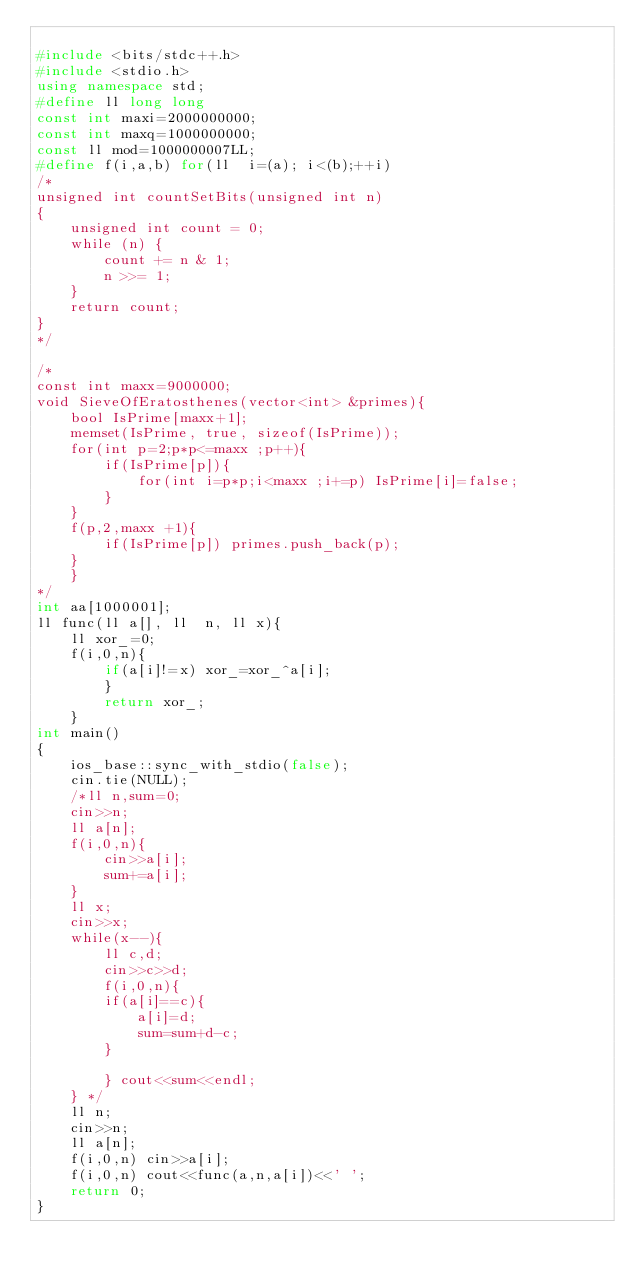<code> <loc_0><loc_0><loc_500><loc_500><_C++_>
#include <bits/stdc++.h>
#include <stdio.h>
using namespace std;
#define ll long long
const int maxi=2000000000;
const int maxq=1000000000;
const ll mod=1000000007LL;
#define f(i,a,b) for(ll  i=(a); i<(b);++i)
/*
unsigned int countSetBits(unsigned int n)
{
    unsigned int count = 0;
    while (n) {
        count += n & 1;
        n >>= 1;
    }
    return count;
}
*/

/*
const int maxx=9000000;
void SieveOfEratosthenes(vector<int> &primes){
    bool IsPrime[maxx+1];
    memset(IsPrime, true, sizeof(IsPrime));
    for(int p=2;p*p<=maxx ;p++){
        if(IsPrime[p]){
            for(int i=p*p;i<maxx ;i+=p) IsPrime[i]=false;
        }
    }
    f(p,2,maxx +1){
        if(IsPrime[p]) primes.push_back(p);
    }
    }
*/
int aa[1000001];
ll func(ll a[], ll  n, ll x){
    ll xor_=0;
    f(i,0,n){
        if(a[i]!=x) xor_=xor_^a[i];
        }
        return xor_;
    }
int main()
{
    ios_base::sync_with_stdio(false);
    cin.tie(NULL);
    /*ll n,sum=0;
    cin>>n;
    ll a[n];
    f(i,0,n){
        cin>>a[i];
        sum+=a[i];
    }
    ll x;
    cin>>x;
    while(x--){
        ll c,d;
        cin>>c>>d;
        f(i,0,n){
        if(a[i]==c){
            a[i]=d;
            sum=sum+d-c;
        }

        } cout<<sum<<endl;
    } */
    ll n;
    cin>>n;
    ll a[n];
    f(i,0,n) cin>>a[i];
    f(i,0,n) cout<<func(a,n,a[i])<<' ';
    return 0;
}


</code> 